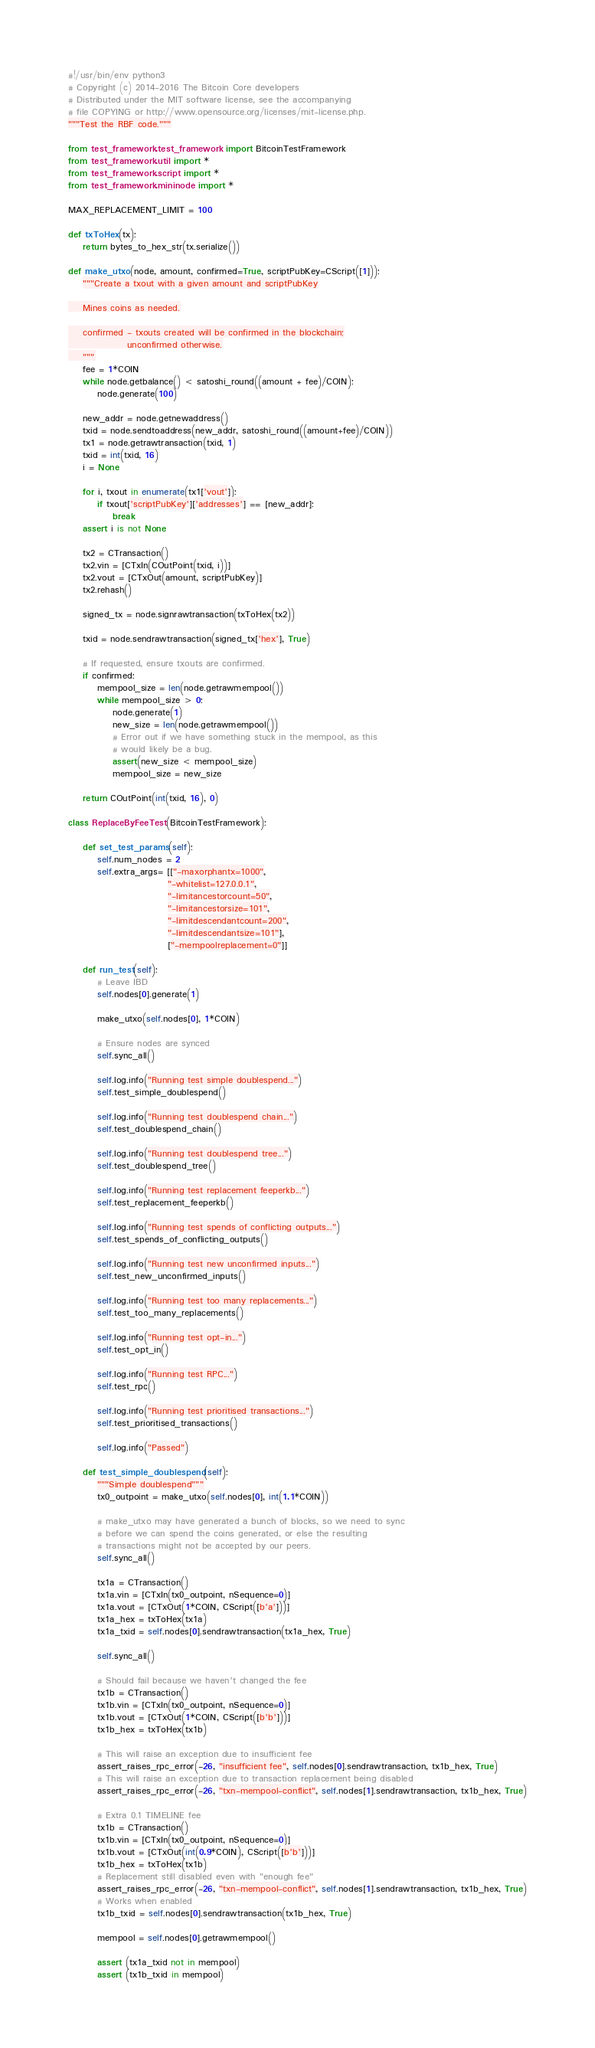<code> <loc_0><loc_0><loc_500><loc_500><_Python_>#!/usr/bin/env python3
# Copyright (c) 2014-2016 The Bitcoin Core developers
# Distributed under the MIT software license, see the accompanying
# file COPYING or http://www.opensource.org/licenses/mit-license.php.
"""Test the RBF code."""

from test_framework.test_framework import BitcoinTestFramework
from test_framework.util import *
from test_framework.script import *
from test_framework.mininode import *

MAX_REPLACEMENT_LIMIT = 100

def txToHex(tx):
    return bytes_to_hex_str(tx.serialize())

def make_utxo(node, amount, confirmed=True, scriptPubKey=CScript([1])):
    """Create a txout with a given amount and scriptPubKey

    Mines coins as needed.

    confirmed - txouts created will be confirmed in the blockchain;
                unconfirmed otherwise.
    """
    fee = 1*COIN
    while node.getbalance() < satoshi_round((amount + fee)/COIN):
        node.generate(100)

    new_addr = node.getnewaddress()
    txid = node.sendtoaddress(new_addr, satoshi_round((amount+fee)/COIN))
    tx1 = node.getrawtransaction(txid, 1)
    txid = int(txid, 16)
    i = None

    for i, txout in enumerate(tx1['vout']):
        if txout['scriptPubKey']['addresses'] == [new_addr]:
            break
    assert i is not None

    tx2 = CTransaction()
    tx2.vin = [CTxIn(COutPoint(txid, i))]
    tx2.vout = [CTxOut(amount, scriptPubKey)]
    tx2.rehash()

    signed_tx = node.signrawtransaction(txToHex(tx2))

    txid = node.sendrawtransaction(signed_tx['hex'], True)

    # If requested, ensure txouts are confirmed.
    if confirmed:
        mempool_size = len(node.getrawmempool())
        while mempool_size > 0:
            node.generate(1)
            new_size = len(node.getrawmempool())
            # Error out if we have something stuck in the mempool, as this
            # would likely be a bug.
            assert(new_size < mempool_size)
            mempool_size = new_size

    return COutPoint(int(txid, 16), 0)

class ReplaceByFeeTest(BitcoinTestFramework):

    def set_test_params(self):
        self.num_nodes = 2
        self.extra_args= [["-maxorphantx=1000",
                           "-whitelist=127.0.0.1",
                           "-limitancestorcount=50",
                           "-limitancestorsize=101",
                           "-limitdescendantcount=200",
                           "-limitdescendantsize=101"],
                           ["-mempoolreplacement=0"]]

    def run_test(self):
        # Leave IBD
        self.nodes[0].generate(1)

        make_utxo(self.nodes[0], 1*COIN)

        # Ensure nodes are synced
        self.sync_all()

        self.log.info("Running test simple doublespend...")
        self.test_simple_doublespend()

        self.log.info("Running test doublespend chain...")
        self.test_doublespend_chain()

        self.log.info("Running test doublespend tree...")
        self.test_doublespend_tree()

        self.log.info("Running test replacement feeperkb...")
        self.test_replacement_feeperkb()

        self.log.info("Running test spends of conflicting outputs...")
        self.test_spends_of_conflicting_outputs()

        self.log.info("Running test new unconfirmed inputs...")
        self.test_new_unconfirmed_inputs()

        self.log.info("Running test too many replacements...")
        self.test_too_many_replacements()

        self.log.info("Running test opt-in...")
        self.test_opt_in()

        self.log.info("Running test RPC...")
        self.test_rpc()

        self.log.info("Running test prioritised transactions...")
        self.test_prioritised_transactions()

        self.log.info("Passed")

    def test_simple_doublespend(self):
        """Simple doublespend"""
        tx0_outpoint = make_utxo(self.nodes[0], int(1.1*COIN))

        # make_utxo may have generated a bunch of blocks, so we need to sync
        # before we can spend the coins generated, or else the resulting
        # transactions might not be accepted by our peers.
        self.sync_all()

        tx1a = CTransaction()
        tx1a.vin = [CTxIn(tx0_outpoint, nSequence=0)]
        tx1a.vout = [CTxOut(1*COIN, CScript([b'a']))]
        tx1a_hex = txToHex(tx1a)
        tx1a_txid = self.nodes[0].sendrawtransaction(tx1a_hex, True)

        self.sync_all()

        # Should fail because we haven't changed the fee
        tx1b = CTransaction()
        tx1b.vin = [CTxIn(tx0_outpoint, nSequence=0)]
        tx1b.vout = [CTxOut(1*COIN, CScript([b'b']))]
        tx1b_hex = txToHex(tx1b)

        # This will raise an exception due to insufficient fee
        assert_raises_rpc_error(-26, "insufficient fee", self.nodes[0].sendrawtransaction, tx1b_hex, True)
        # This will raise an exception due to transaction replacement being disabled
        assert_raises_rpc_error(-26, "txn-mempool-conflict", self.nodes[1].sendrawtransaction, tx1b_hex, True)

        # Extra 0.1 TIMELINE fee
        tx1b = CTransaction()
        tx1b.vin = [CTxIn(tx0_outpoint, nSequence=0)]
        tx1b.vout = [CTxOut(int(0.9*COIN), CScript([b'b']))]
        tx1b_hex = txToHex(tx1b)
        # Replacement still disabled even with "enough fee"
        assert_raises_rpc_error(-26, "txn-mempool-conflict", self.nodes[1].sendrawtransaction, tx1b_hex, True)
        # Works when enabled
        tx1b_txid = self.nodes[0].sendrawtransaction(tx1b_hex, True)

        mempool = self.nodes[0].getrawmempool()

        assert (tx1a_txid not in mempool)
        assert (tx1b_txid in mempool)
</code> 